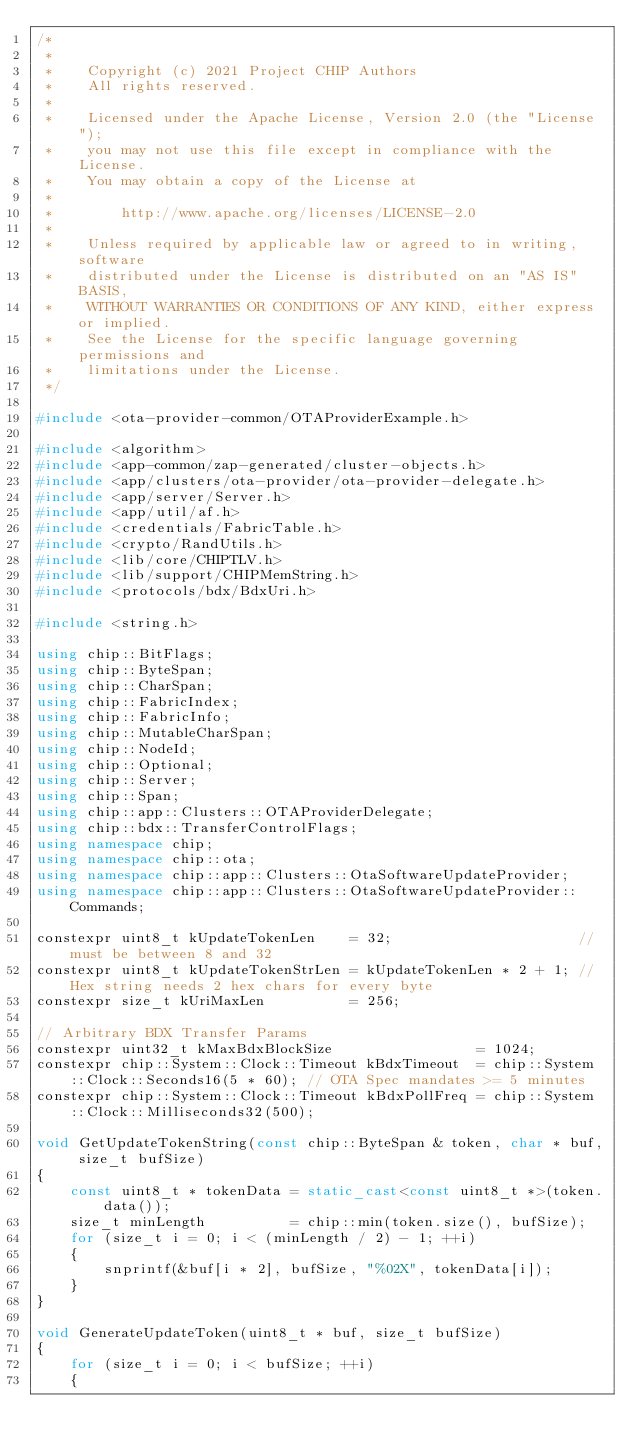<code> <loc_0><loc_0><loc_500><loc_500><_C++_>/*
 *
 *    Copyright (c) 2021 Project CHIP Authors
 *    All rights reserved.
 *
 *    Licensed under the Apache License, Version 2.0 (the "License");
 *    you may not use this file except in compliance with the License.
 *    You may obtain a copy of the License at
 *
 *        http://www.apache.org/licenses/LICENSE-2.0
 *
 *    Unless required by applicable law or agreed to in writing, software
 *    distributed under the License is distributed on an "AS IS" BASIS,
 *    WITHOUT WARRANTIES OR CONDITIONS OF ANY KIND, either express or implied.
 *    See the License for the specific language governing permissions and
 *    limitations under the License.
 */

#include <ota-provider-common/OTAProviderExample.h>

#include <algorithm>
#include <app-common/zap-generated/cluster-objects.h>
#include <app/clusters/ota-provider/ota-provider-delegate.h>
#include <app/server/Server.h>
#include <app/util/af.h>
#include <credentials/FabricTable.h>
#include <crypto/RandUtils.h>
#include <lib/core/CHIPTLV.h>
#include <lib/support/CHIPMemString.h>
#include <protocols/bdx/BdxUri.h>

#include <string.h>

using chip::BitFlags;
using chip::ByteSpan;
using chip::CharSpan;
using chip::FabricIndex;
using chip::FabricInfo;
using chip::MutableCharSpan;
using chip::NodeId;
using chip::Optional;
using chip::Server;
using chip::Span;
using chip::app::Clusters::OTAProviderDelegate;
using chip::bdx::TransferControlFlags;
using namespace chip;
using namespace chip::ota;
using namespace chip::app::Clusters::OtaSoftwareUpdateProvider;
using namespace chip::app::Clusters::OtaSoftwareUpdateProvider::Commands;

constexpr uint8_t kUpdateTokenLen    = 32;                      // must be between 8 and 32
constexpr uint8_t kUpdateTokenStrLen = kUpdateTokenLen * 2 + 1; // Hex string needs 2 hex chars for every byte
constexpr size_t kUriMaxLen          = 256;

// Arbitrary BDX Transfer Params
constexpr uint32_t kMaxBdxBlockSize                 = 1024;
constexpr chip::System::Clock::Timeout kBdxTimeout  = chip::System::Clock::Seconds16(5 * 60); // OTA Spec mandates >= 5 minutes
constexpr chip::System::Clock::Timeout kBdxPollFreq = chip::System::Clock::Milliseconds32(500);

void GetUpdateTokenString(const chip::ByteSpan & token, char * buf, size_t bufSize)
{
    const uint8_t * tokenData = static_cast<const uint8_t *>(token.data());
    size_t minLength          = chip::min(token.size(), bufSize);
    for (size_t i = 0; i < (minLength / 2) - 1; ++i)
    {
        snprintf(&buf[i * 2], bufSize, "%02X", tokenData[i]);
    }
}

void GenerateUpdateToken(uint8_t * buf, size_t bufSize)
{
    for (size_t i = 0; i < bufSize; ++i)
    {</code> 